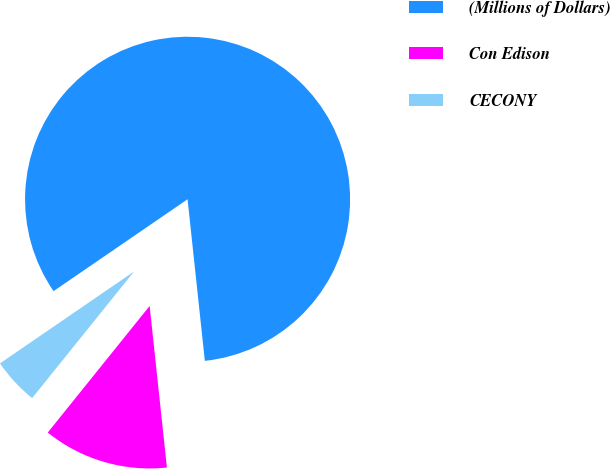Convert chart to OTSL. <chart><loc_0><loc_0><loc_500><loc_500><pie_chart><fcel>(Millions of Dollars)<fcel>Con Edison<fcel>CECONY<nl><fcel>82.87%<fcel>12.48%<fcel>4.65%<nl></chart> 